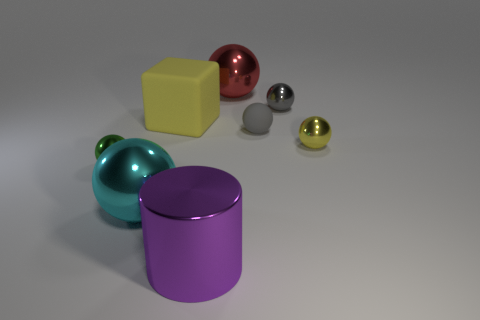How many things are small green metallic objects or large balls in front of the block?
Keep it short and to the point. 2. There is a rubber ball; is it the same size as the shiny sphere that is on the left side of the cyan metallic thing?
Your response must be concise. Yes. What number of blocks are big objects or tiny green objects?
Ensure brevity in your answer.  1. What number of small metallic balls are both right of the cyan ball and on the left side of the big block?
Give a very brief answer. 0. What number of other things are there of the same color as the metallic cylinder?
Offer a terse response. 0. There is a tiny metal thing in front of the small yellow ball; what shape is it?
Your answer should be compact. Sphere. Does the tiny green thing have the same material as the red thing?
Give a very brief answer. Yes. Are there any other things that are the same size as the cyan metal ball?
Provide a succinct answer. Yes. There is a red shiny object; what number of small matte balls are to the left of it?
Provide a succinct answer. 0. There is a rubber thing left of the thing that is in front of the big cyan object; what shape is it?
Your answer should be very brief. Cube. 